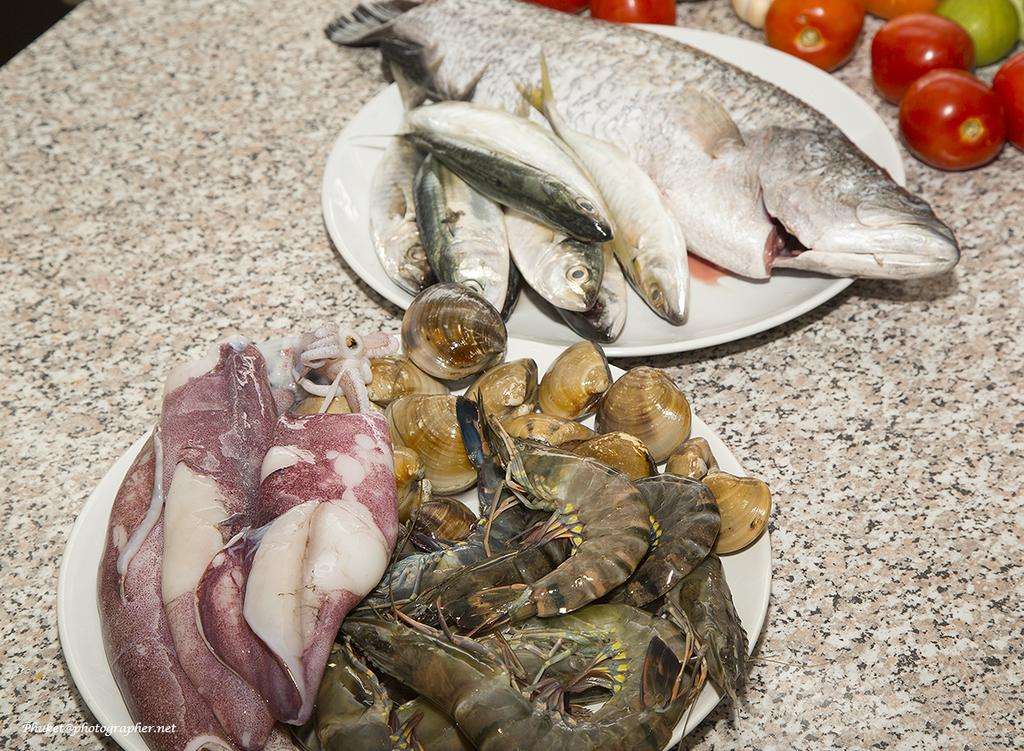What type of food is on the plates in the image? There is seafood on plates in the image. What other type of food can be seen on the table in the image? There are vegetables on the table in the image. Can you describe any text that is visible in the image? Yes, there is text at the bottom of the image. Can you tell me how many strangers are present in the image? There is no stranger present in the image. Is there an airplane visible in the image? No, there is no airplane present in the image. 